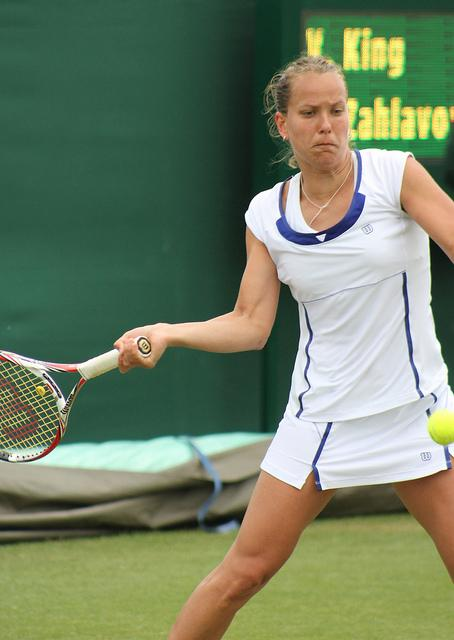What shot is this player making? Please explain your reasoning. forehand. The player is presenting the front of their arm, giving the shot its name. 